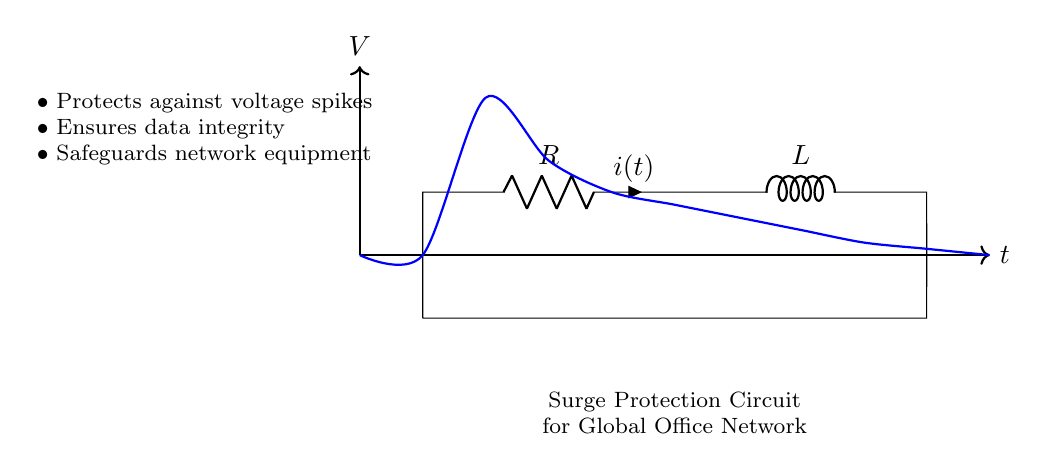What components are in the circuit? The circuit contains a resistor (R) and an inductor (L), which are both connected in series as shown in the diagram.
Answer: Resistor and Inductor What is the direction of the current in the circuit? The current (i(t)) flows through the resistor and inductor, indicated by the arrow pointing from the resistor to the inductor in the diagram.
Answer: From resistor to inductor What type of circuit is represented here? The circuit is a resistor-inductor (RL) circuit, specifically used for surge protection, as indicated in the context of the diagram.
Answer: Resistor-Inductor What does the circuit protect against? The circuit serves to protect against voltage spikes, as mentioned in the bullet points on the left side of the diagram.
Answer: Voltage spikes How does this circuit ensure data integrity? The circuit's design with a resistor and inductor helps stabilize voltage levels, thereby ensuring that data transmitted through the network is not corrupted by surges.
Answer: By stabilizing voltage What is the primary function of the inductor in this circuit? The inductor primarily functions to resist changes in current, which helps to suppress sudden surges, protecting the connected equipment.
Answer: To resist changes in current What effect does the resistor have in the surge protection circuit? The resistor helps dissipate energy and limits the amount of current that can flow during a surge, thereby providing protection to connected equipment.
Answer: Limits current flow 